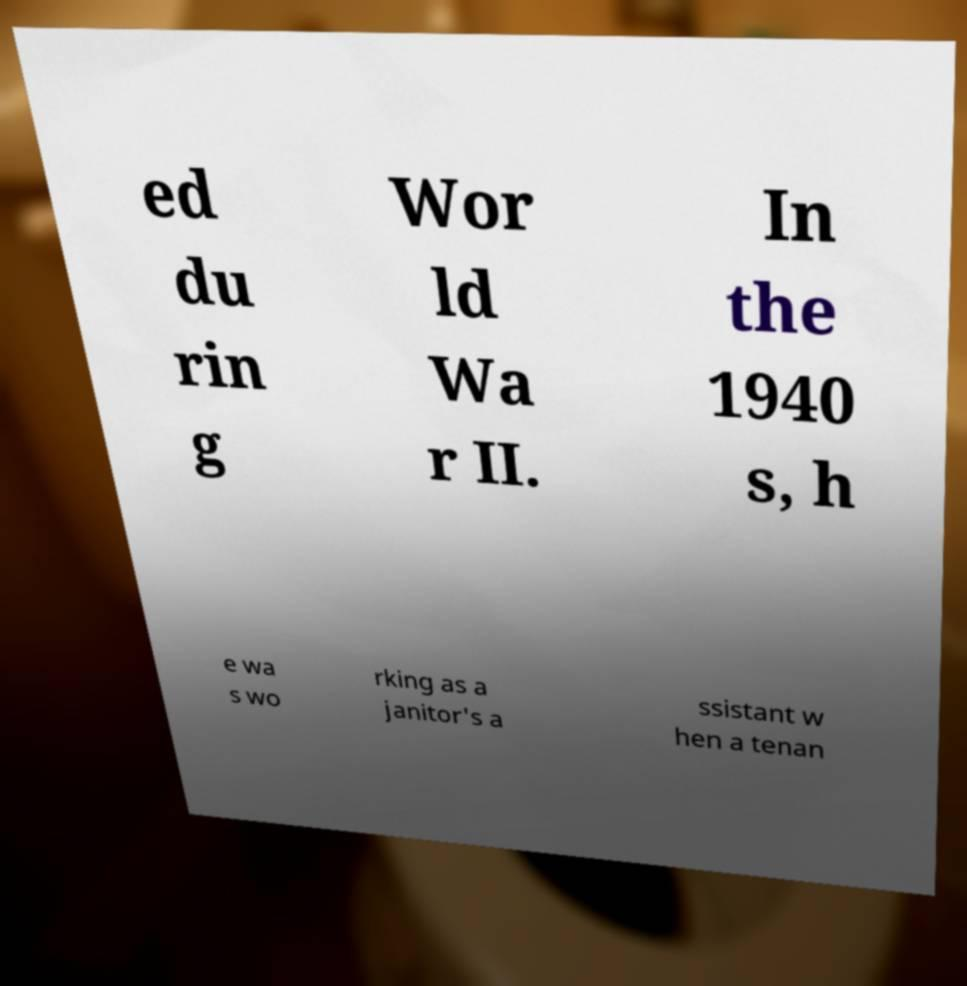Please identify and transcribe the text found in this image. ed du rin g Wor ld Wa r II. In the 1940 s, h e wa s wo rking as a janitor's a ssistant w hen a tenan 